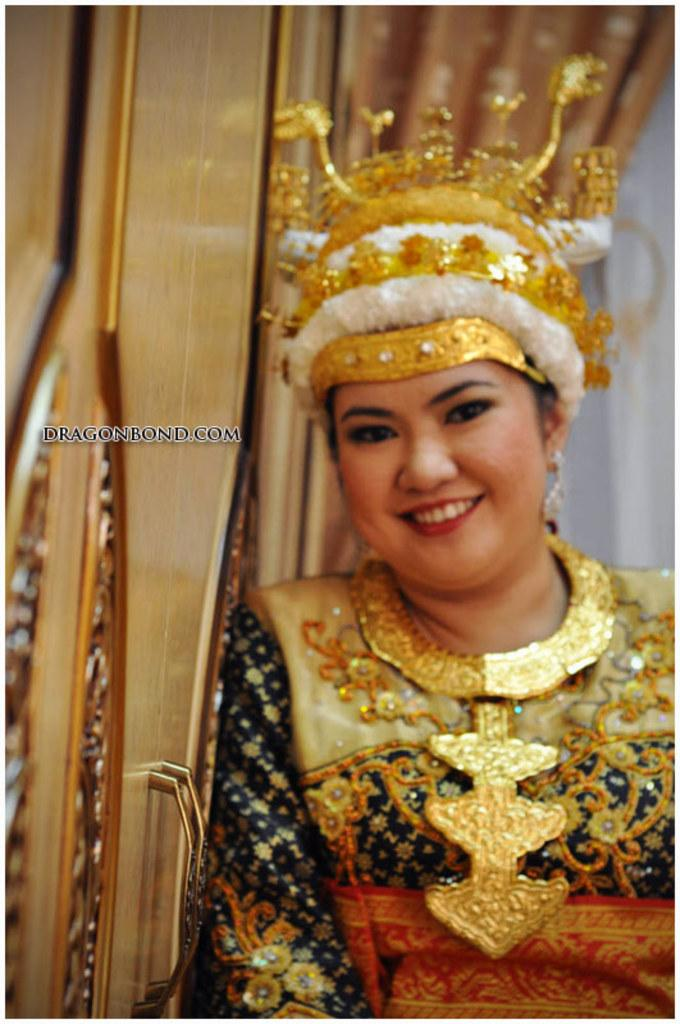Who or what is in the image? There is a person in the image. What is the person wearing on their head? The person is wearing a crown. What other accessory is the person wearing? The person is wearing a necklace. What can be seen on the left side of the image? There is a door on the left side of the image. How many corks are visible in the image? There are no corks present in the image. What type of bikes are being ridden by the person in the image? There are no bikes present in the image. 